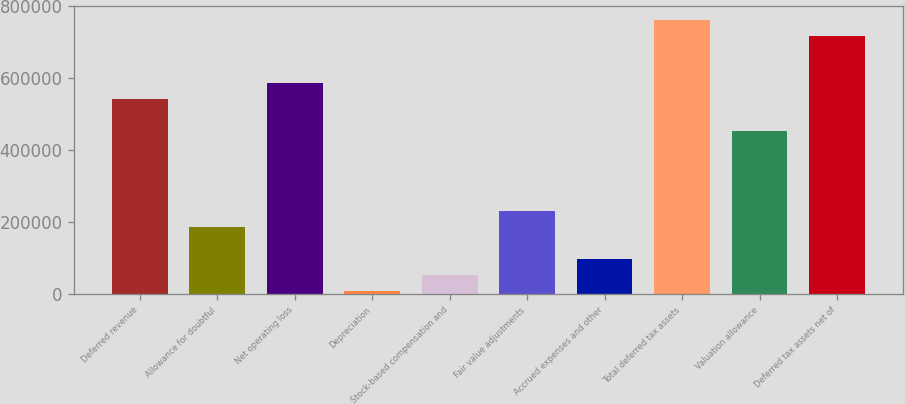<chart> <loc_0><loc_0><loc_500><loc_500><bar_chart><fcel>Deferred revenue<fcel>Allowance for doubtful<fcel>Net operating loss<fcel>Depreciation<fcel>Stock-based compensation and<fcel>Fair value adjustments<fcel>Accrued expenses and other<fcel>Total deferred tax assets<fcel>Valuation allowance<fcel>Deferred tax assets net of<nl><fcel>541035<fcel>185714<fcel>585451<fcel>8053<fcel>52468.2<fcel>230129<fcel>96883.4<fcel>763111<fcel>452205<fcel>718696<nl></chart> 